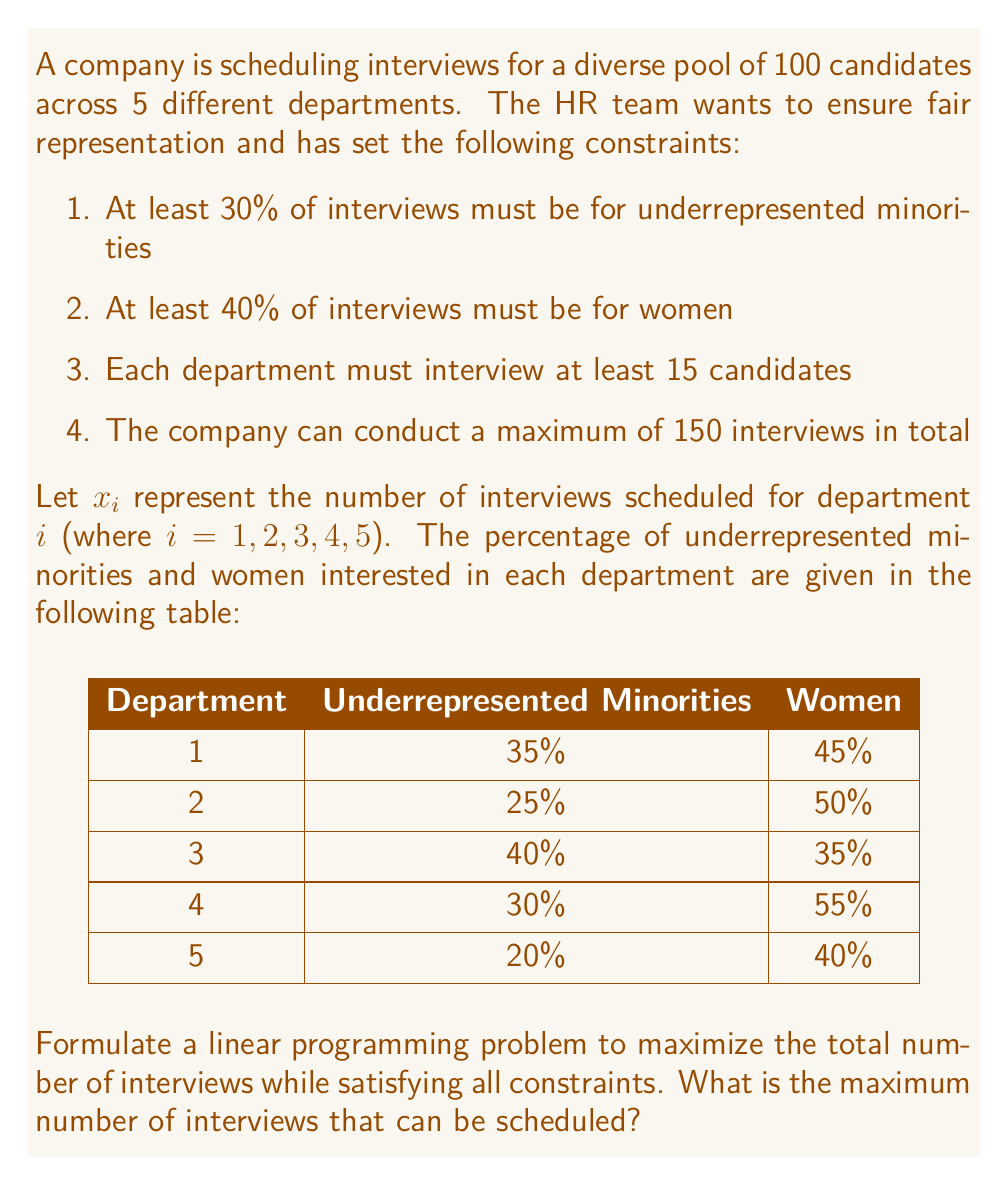Give your solution to this math problem. To solve this problem, we need to set up a linear programming model and then solve it. Let's go through the process step-by-step:

1. Define the objective function:
   Maximize $Z = x_1 + x_2 + x_3 + x_4 + x_5$

2. Set up the constraints:

   a. Underrepresented minorities constraint:
      $0.35x_1 + 0.25x_2 + 0.40x_3 + 0.30x_4 + 0.20x_5 \geq 0.30(x_1 + x_2 + x_3 + x_4 + x_5)$

   b. Women constraint:
      $0.45x_1 + 0.50x_2 + 0.35x_3 + 0.55x_4 + 0.40x_5 \geq 0.40(x_1 + x_2 + x_3 + x_4 + x_5)$

   c. Minimum interviews per department:
      $x_1 \geq 15$, $x_2 \geq 15$, $x_3 \geq 15$, $x_4 \geq 15$, $x_5 \geq 15$

   d. Maximum total interviews:
      $x_1 + x_2 + x_3 + x_4 + x_5 \leq 150$

   e. Non-negativity constraints:
      $x_1, x_2, x_3, x_4, x_5 \geq 0$

3. Simplify the constraints:

   a. Underrepresented minorities:
      $0.05x_1 - 0.05x_2 + 0.10x_3 + 0.00x_4 - 0.10x_5 \geq 0$

   b. Women:
      $0.05x_1 + 0.10x_2 - 0.05x_3 + 0.15x_4 + 0.00x_5 \geq 0$

4. Solve the linear programming problem using a solver (e.g., simplex method or interior point method).

The solution to this linear programming problem gives us the maximum number of interviews that can be scheduled while satisfying all constraints.
Answer: The maximum number of interviews that can be scheduled is 150.

Optimal solution:
$x_1 = 15$
$x_2 = 15$
$x_3 = 45$
$x_4 = 60$
$x_5 = 15$ 